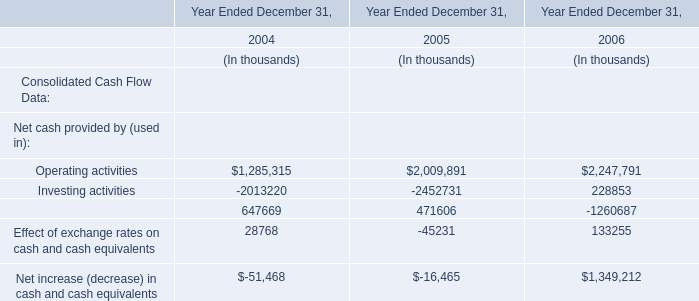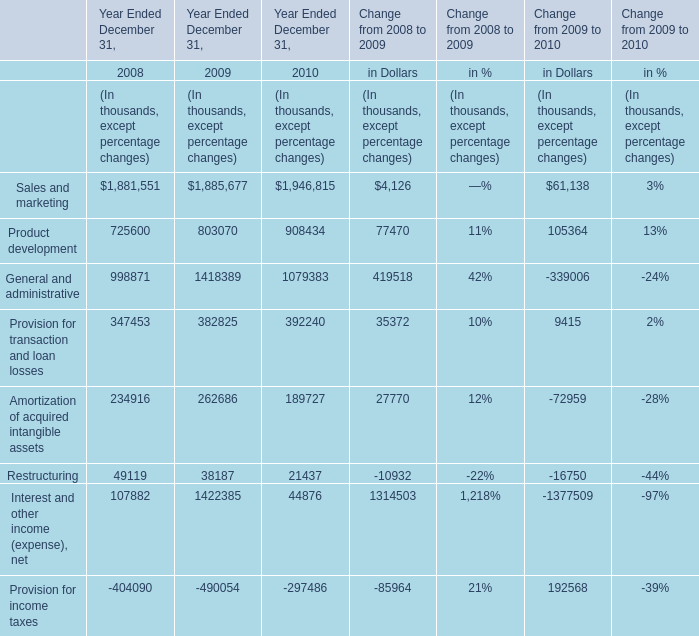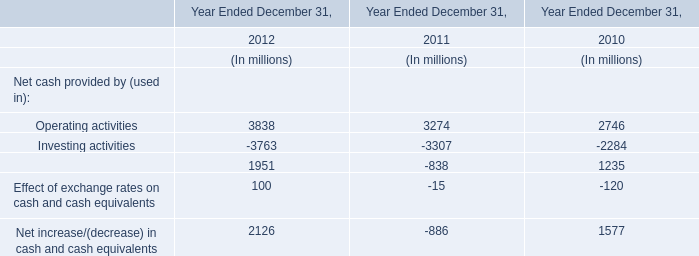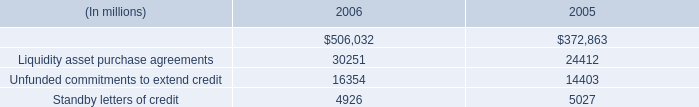what is the percentage change in the balance of indemnified securities financing from 2005 to 2006? 
Computations: ((506032 - 372863) / 372863)
Answer: 0.35715. 